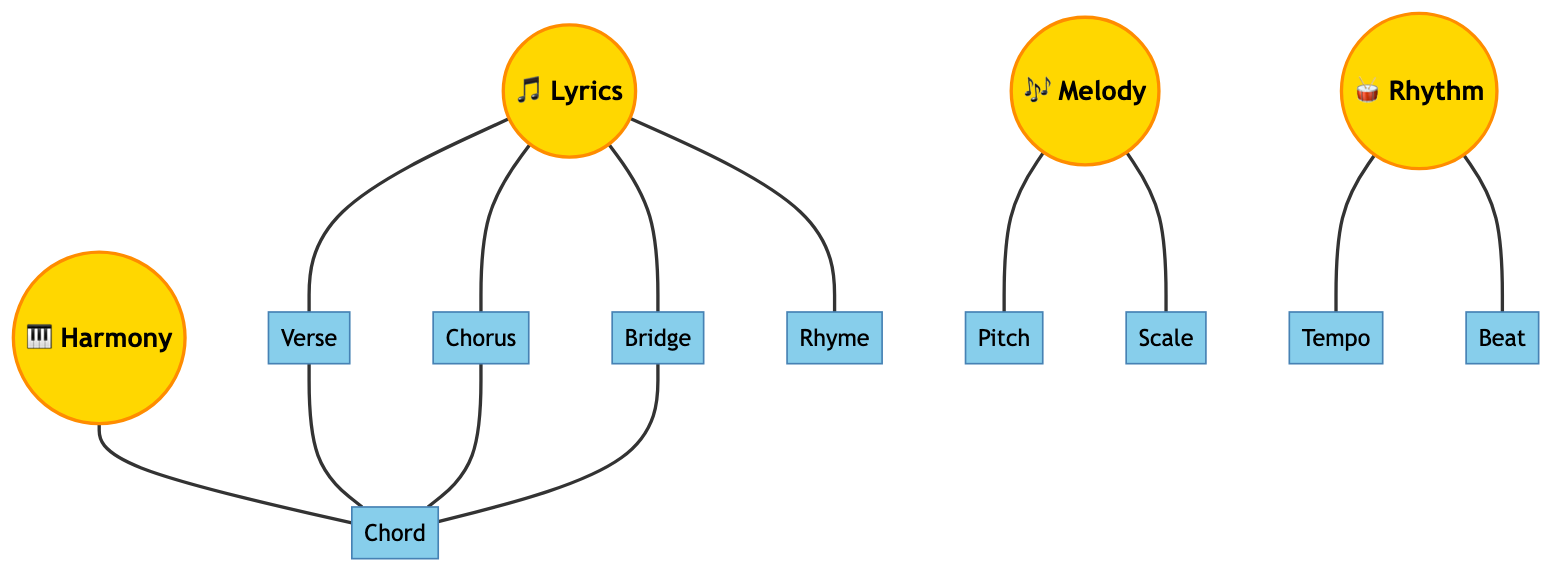What are the main elements of a song represented in the diagram? The main elements of a song shown in the diagram are Lyrics, Melody, Rhythm, and Harmony. These four nodes are significant because they represent core components of music creation.
Answer: Lyrics, Melody, Rhythm, Harmony How many sub-elements are connected to Lyrics? The diagram shows that Lyrics is connected to four sub-elements: Verse, Chorus, Bridge, and Rhyme. Each of these elements elaborates on the structure or theme of the song's lyrics.
Answer: 4 What sub-element is connected to Melody? The diagram indicates that Melody connects to two sub-elements: Pitch and Scale. These are important for defining the tonal quality and framework of the melody.
Answer: Pitch, Scale Which element has the most connections in the diagram? Analyzing the diagram, Lyrics has the most connections, with four direct edges leading to Verse, Chorus, Bridge, and Rhyme. This emphasizes the importance of lyrics in structuring a song.
Answer: Lyrics How many edges are present in the diagram? The total number of edges can be calculated by counting each line connecting the nodes. There are ten edges in total, representing the relationships between main and sub-elements.
Answer: 10 Which two elements are connected through the Chord sub-element? The edges show that both Verse and Chorus connect through the Chord element, indicating that Chord is a common aspect of both these parts of a song.
Answer: Verse, Chorus What element connects Rhythm to Tempo? The diagram directly links Rhythm to Tempo, suggesting that Tempo is an essential feature within the overall rhythmic structure of a song.
Answer: Tempo What is one of the sub-elements of Harmony? Harmony has one direct sub-element connected, which is Chord. This indicates that chords are fundamental to creating harmony in music.
Answer: Chord 